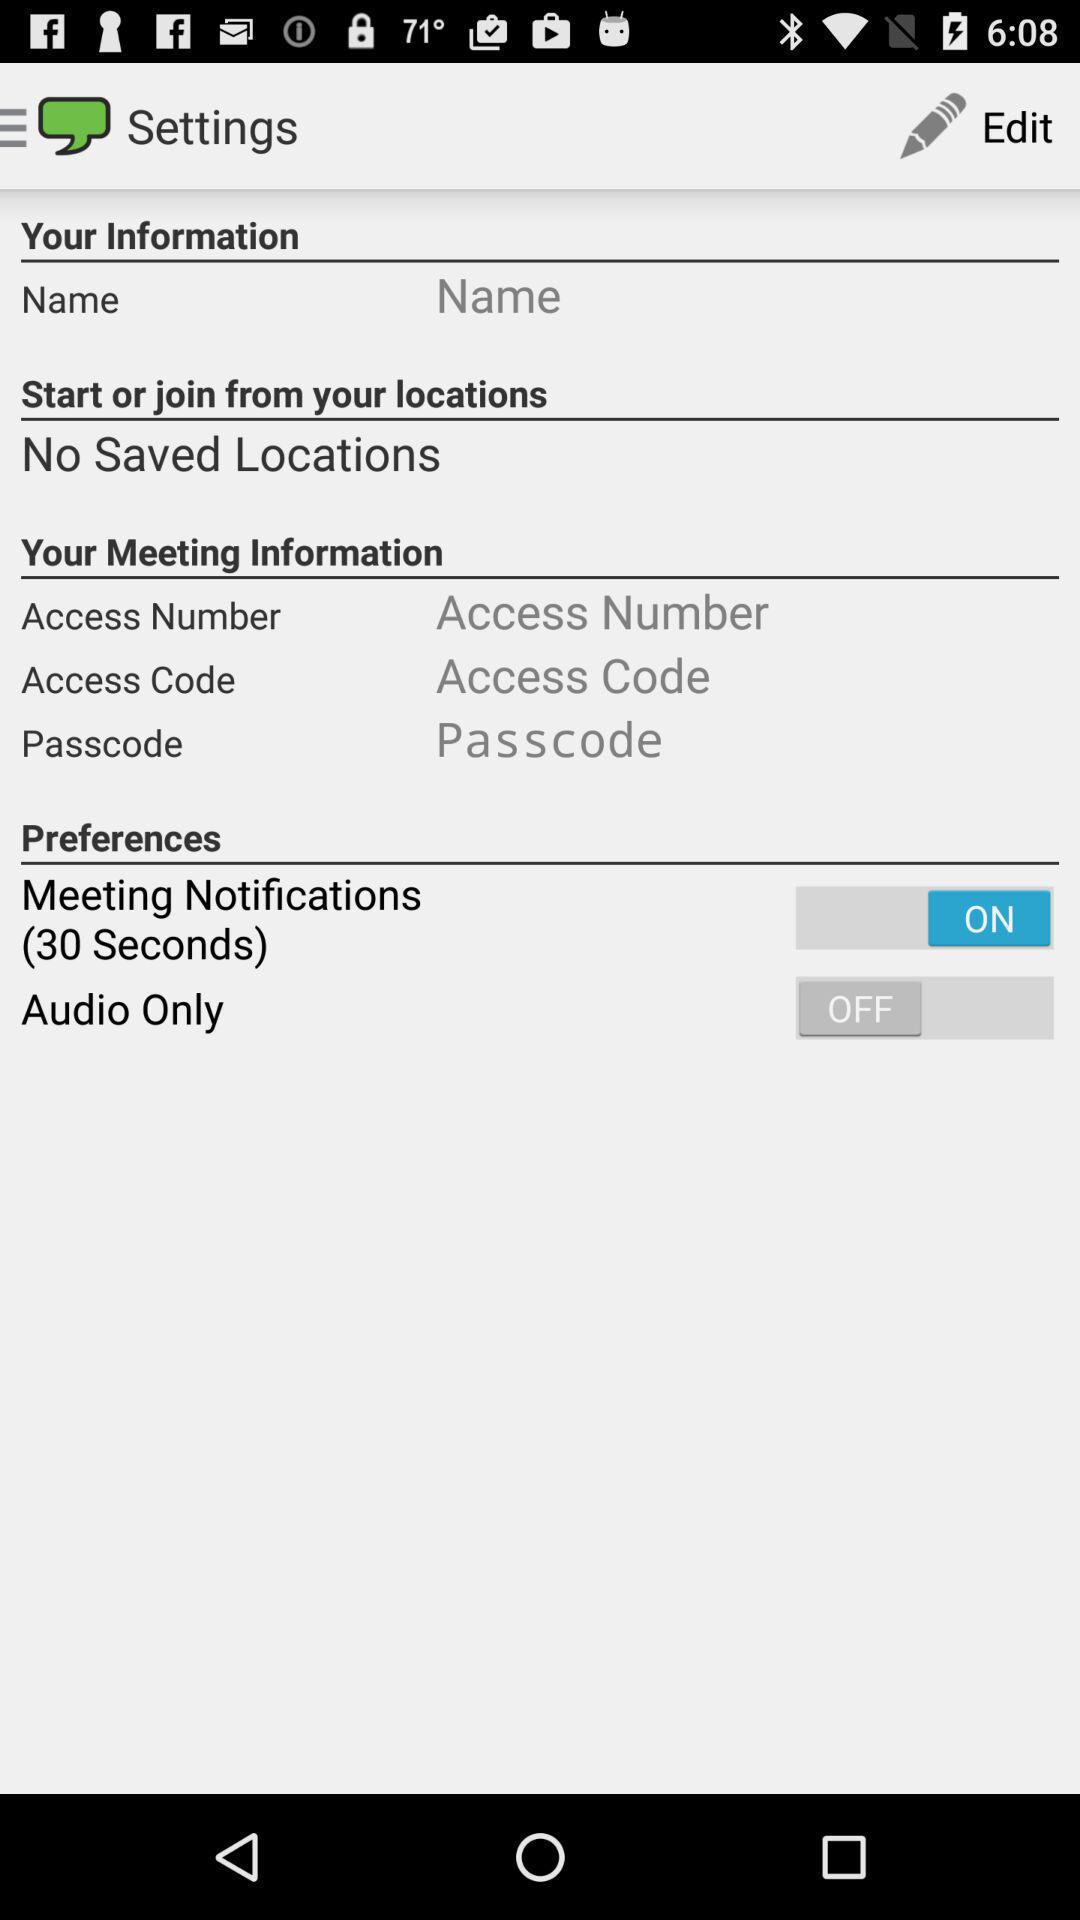What is the duration mentioned beside "Meeting Notifications"? The duration mentioned beside "Meeting Notifications" is 30 seconds. 